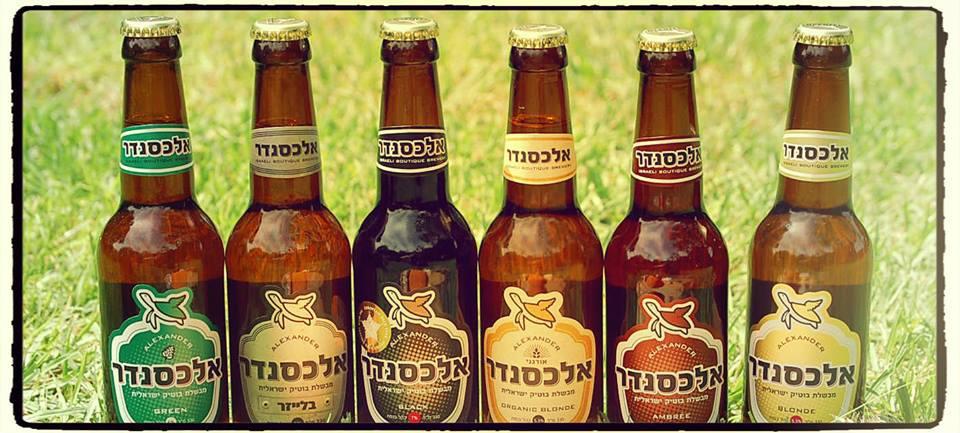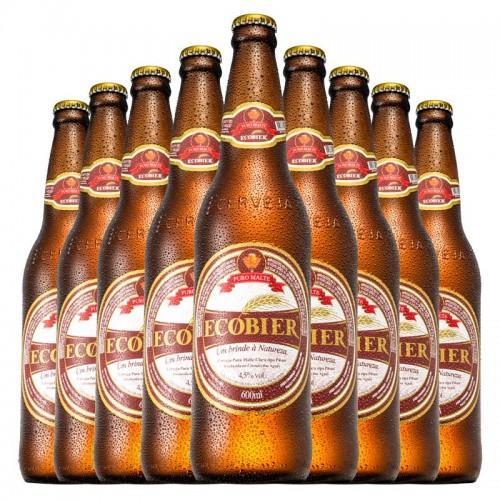The first image is the image on the left, the second image is the image on the right. For the images displayed, is the sentence "There are more than ten bottles in total." factually correct? Answer yes or no. Yes. The first image is the image on the left, the second image is the image on the right. For the images displayed, is the sentence "There are more than 10 bottles." factually correct? Answer yes or no. Yes. 